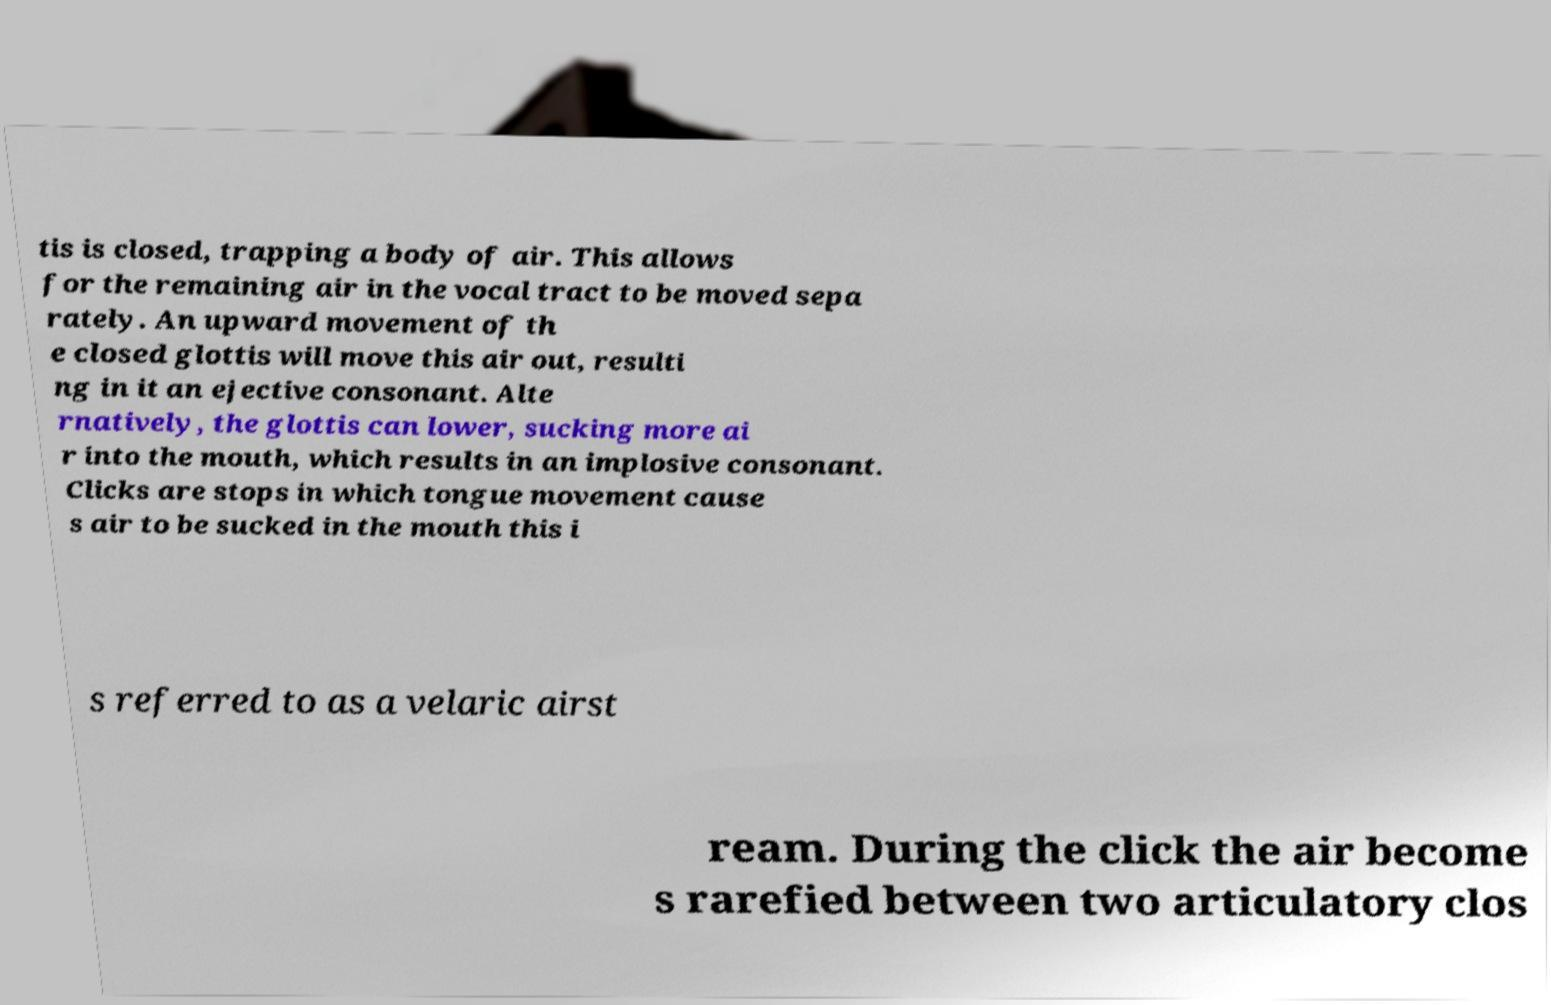For documentation purposes, I need the text within this image transcribed. Could you provide that? tis is closed, trapping a body of air. This allows for the remaining air in the vocal tract to be moved sepa rately. An upward movement of th e closed glottis will move this air out, resulti ng in it an ejective consonant. Alte rnatively, the glottis can lower, sucking more ai r into the mouth, which results in an implosive consonant. Clicks are stops in which tongue movement cause s air to be sucked in the mouth this i s referred to as a velaric airst ream. During the click the air become s rarefied between two articulatory clos 